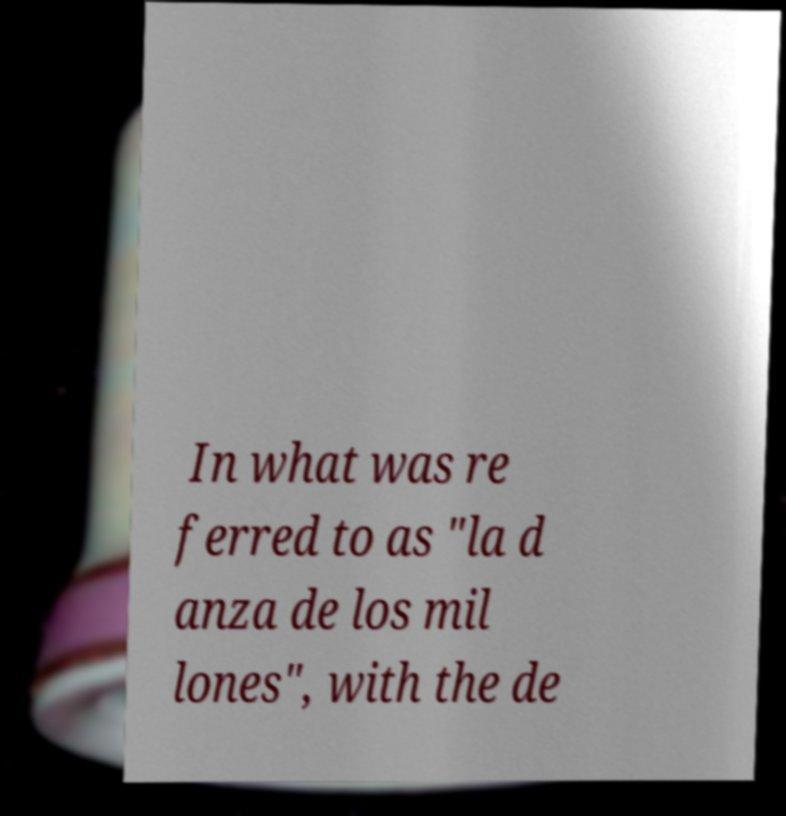For documentation purposes, I need the text within this image transcribed. Could you provide that? In what was re ferred to as "la d anza de los mil lones", with the de 